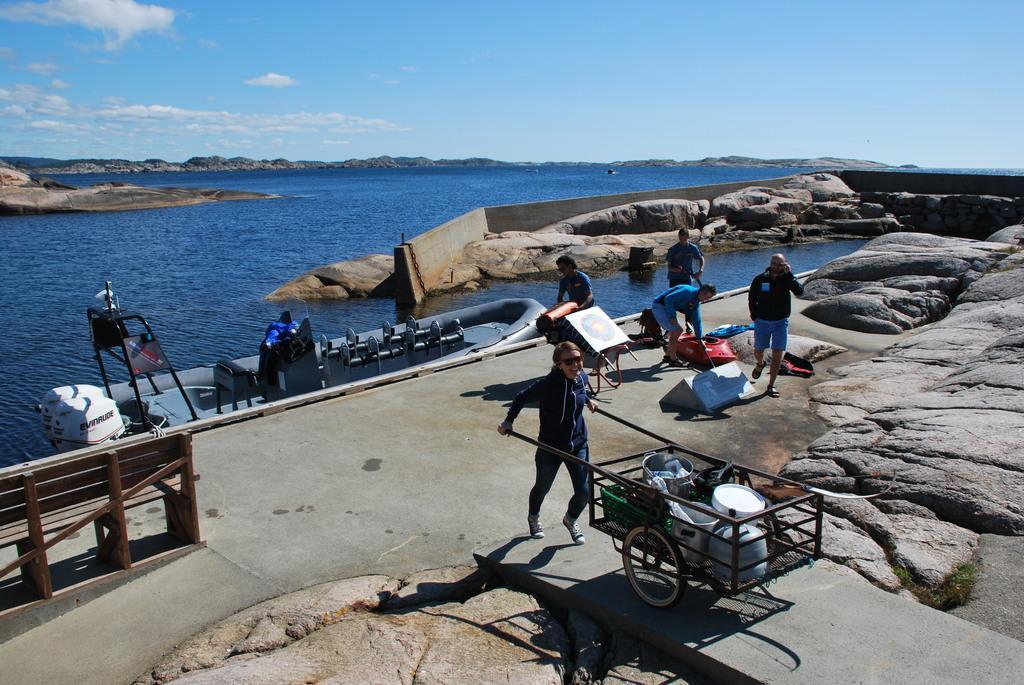Please provide a concise description of this image. In this picture we can see there are groups of people on the path and a person is pushing a cart. Behind the people there is a boat on the water, rocks and a wall. Behind the wall there are hills and a sky. 